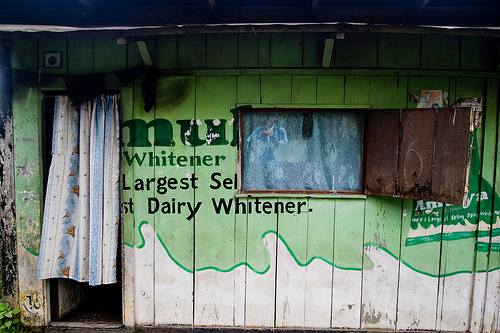<image>
Can you confirm if the curtain is on the ground? No. The curtain is not positioned on the ground. They may be near each other, but the curtain is not supported by or resting on top of the ground. Where is the house in relation to the window? Is it in front of the window? No. The house is not in front of the window. The spatial positioning shows a different relationship between these objects. 